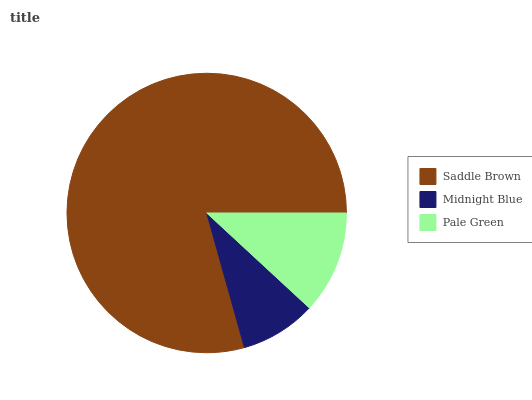Is Midnight Blue the minimum?
Answer yes or no. Yes. Is Saddle Brown the maximum?
Answer yes or no. Yes. Is Pale Green the minimum?
Answer yes or no. No. Is Pale Green the maximum?
Answer yes or no. No. Is Pale Green greater than Midnight Blue?
Answer yes or no. Yes. Is Midnight Blue less than Pale Green?
Answer yes or no. Yes. Is Midnight Blue greater than Pale Green?
Answer yes or no. No. Is Pale Green less than Midnight Blue?
Answer yes or no. No. Is Pale Green the high median?
Answer yes or no. Yes. Is Pale Green the low median?
Answer yes or no. Yes. Is Saddle Brown the high median?
Answer yes or no. No. Is Midnight Blue the low median?
Answer yes or no. No. 